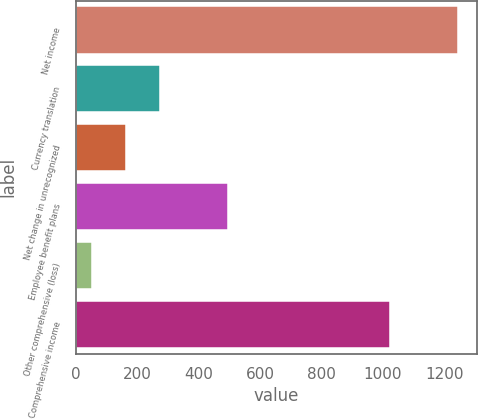Convert chart. <chart><loc_0><loc_0><loc_500><loc_500><bar_chart><fcel>Net income<fcel>Currency translation<fcel>Net change in unrecognized<fcel>Employee benefit plans<fcel>Other comprehensive (loss)<fcel>Comprehensive income<nl><fcel>1244.6<fcel>273.6<fcel>162.8<fcel>495.2<fcel>52<fcel>1023<nl></chart> 